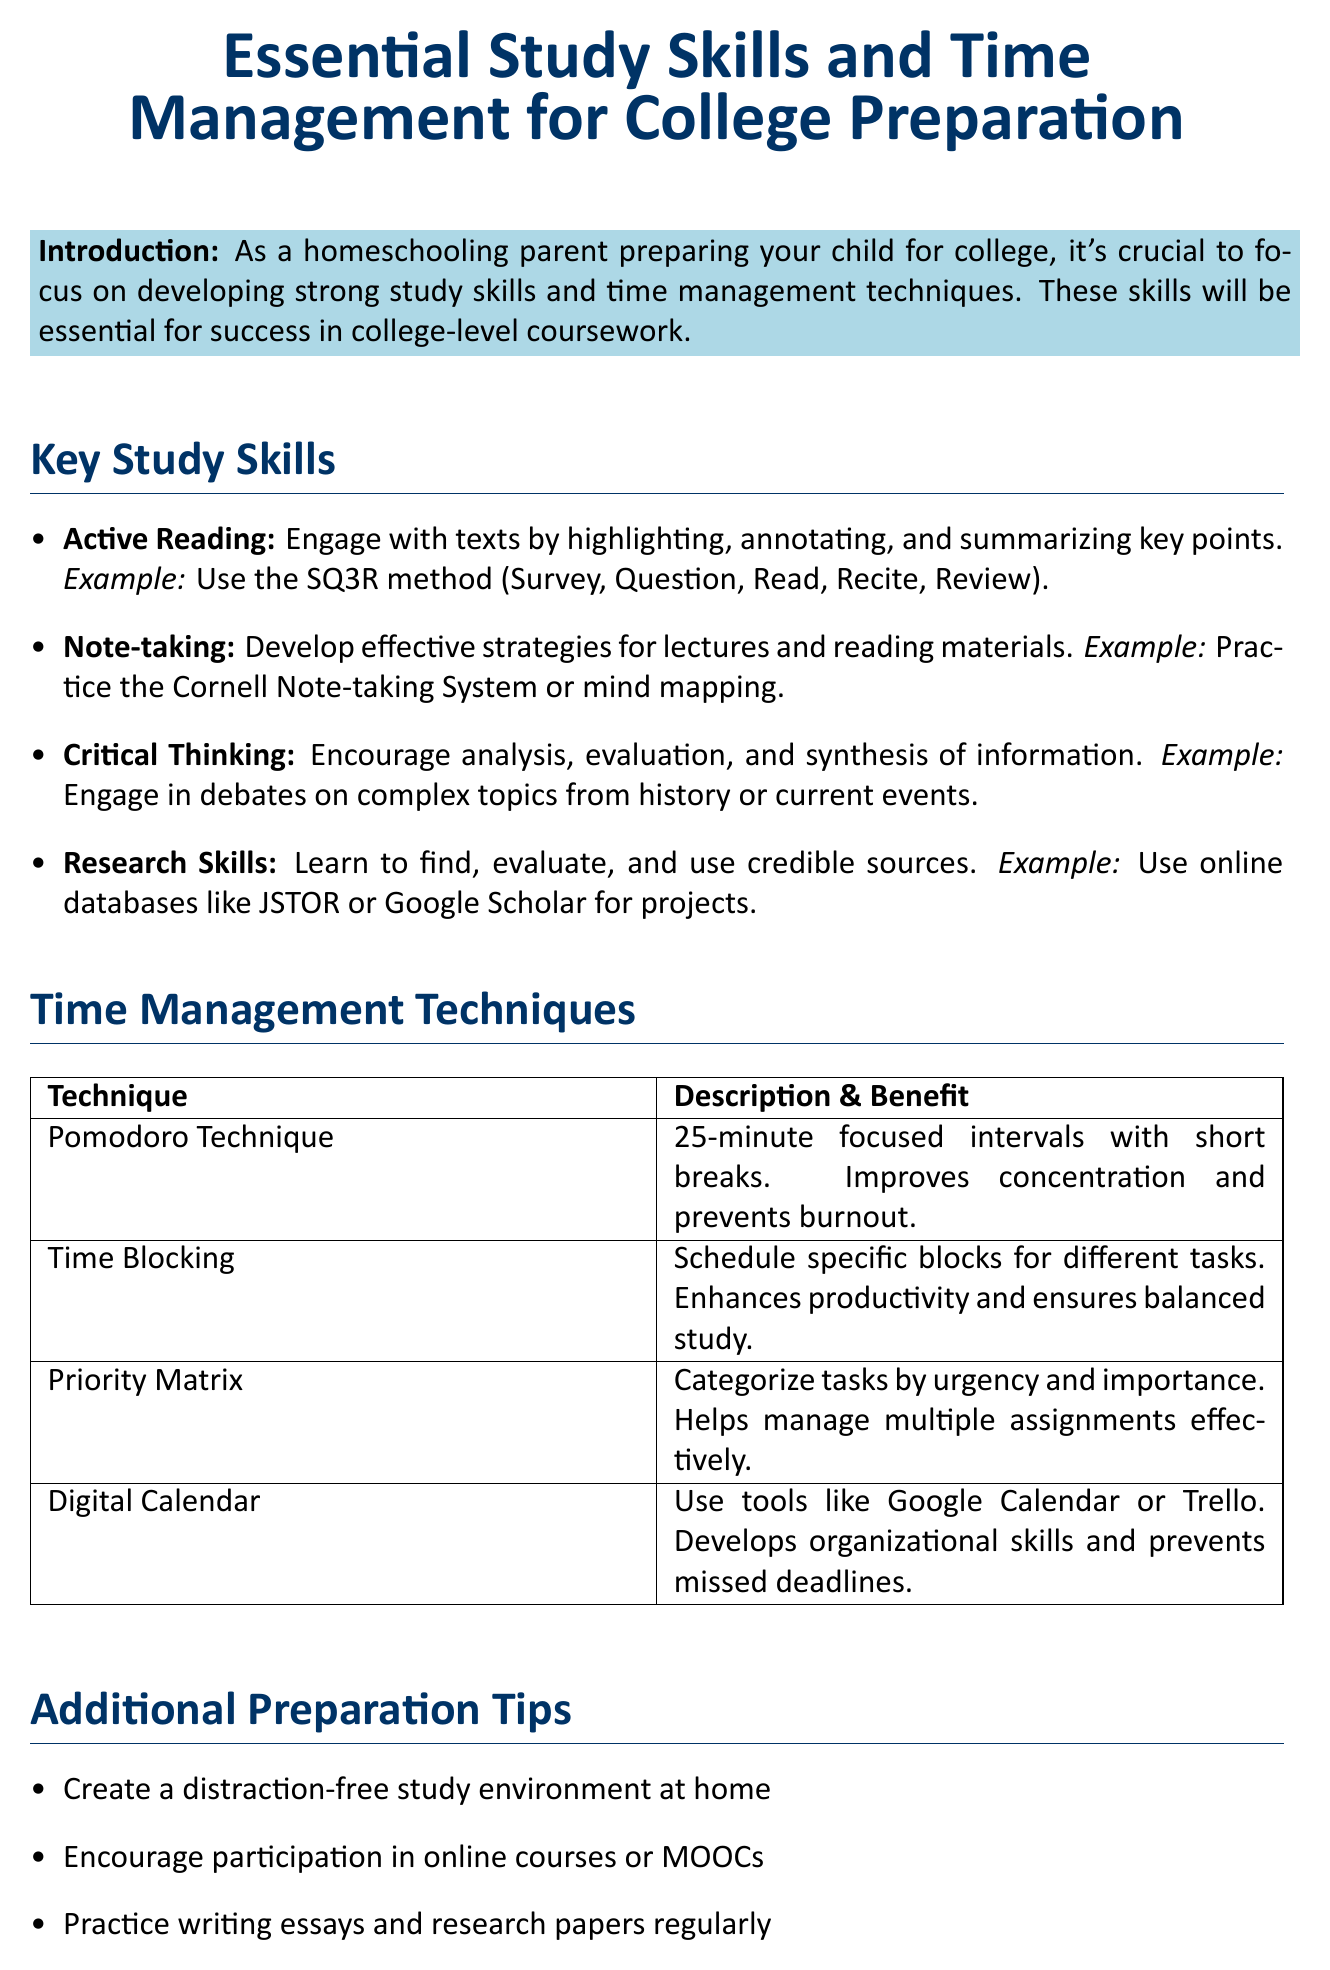What is the title of the memo? The title of the memo is stated at the beginning and provides an overview of the subject matter.
Answer: Essential Study Skills and Time Management for College Preparation What is one essential study skill mentioned in the memo? The memo lists several study skills designed to aid in college preparation.
Answer: Active Reading What is the benefit of the Pomodoro Technique? This technique is designed to improve concentration and prevent burnout during study sessions.
Answer: Improves concentration and prevents burnout Which note-taking strategy is mentioned as an example? The memo provides specific strategies as examples for effective note-taking.
Answer: Cornell Note-taking System What does the Priority Matrix help with? This technique assists in managing tasks that require prioritization based on certain criteria.
Answer: Helps manage multiple assignments effectively What is one additional preparation tip? The memo includes a list of tips aimed at further enhancing preparation for college.
Answer: Create a distraction-free study environment at home How many time management techniques are outlined in the document? The memo enumerates distinct techniques to aid in time management.
Answer: Four What is the purpose of the memo? The memo is designed to help homeschooling parents equip their children with necessary skills for college.
Answer: To prepare children for college-level coursework 